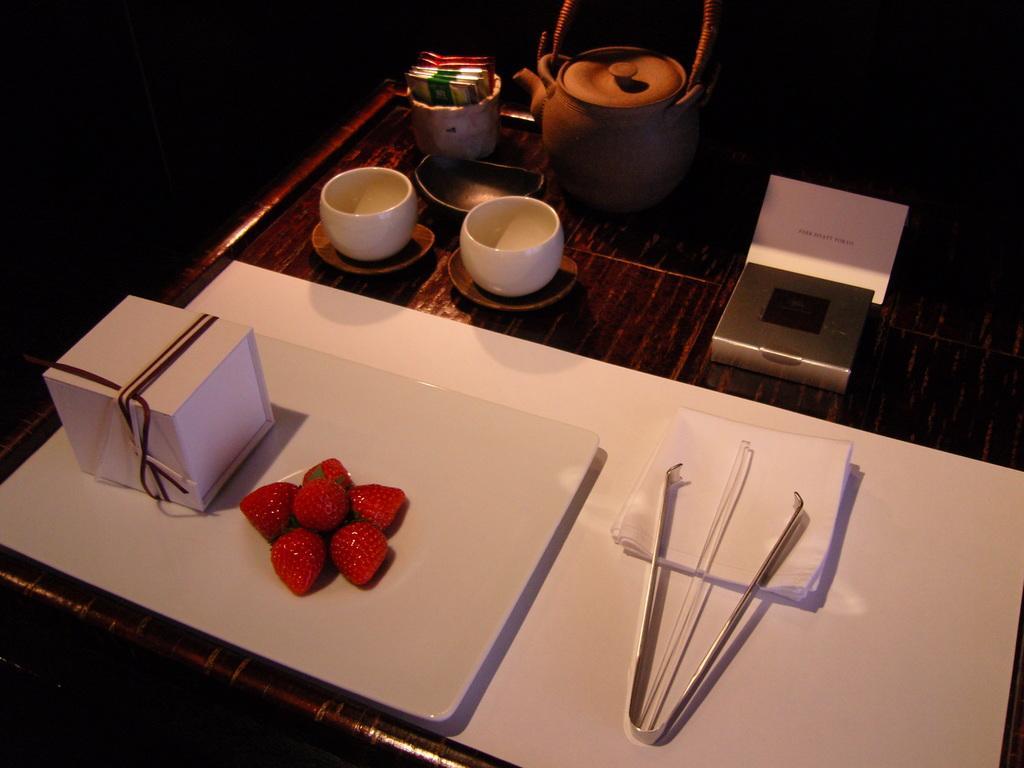Could you give a brief overview of what you see in this image? In the image we can see there is a table on which there is a kettle, cups and box and a tray strawberries. 